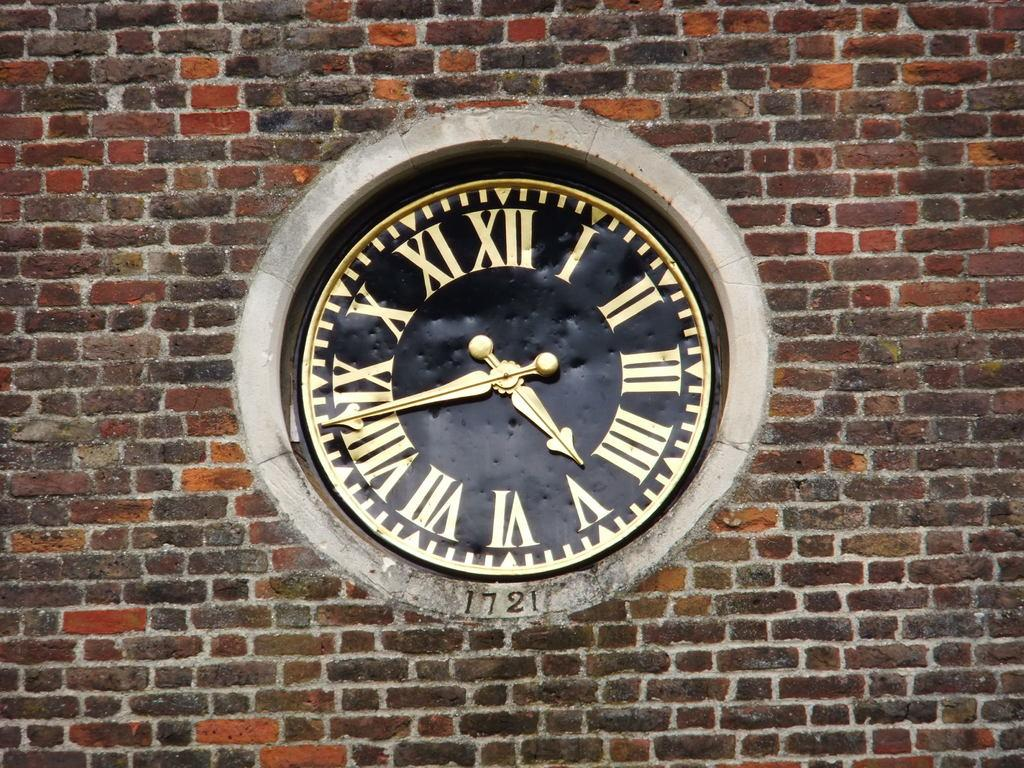<image>
Render a clear and concise summary of the photo. An old black and gold clock made in 1721 